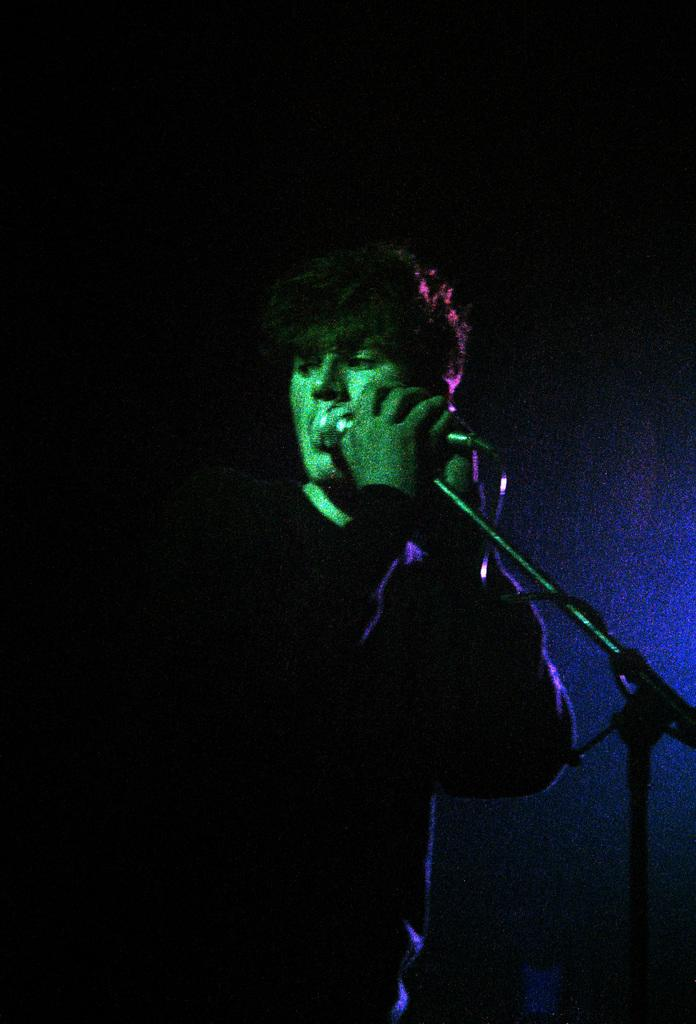What is the main subject of the image? There is a person standing in the image. What is the person holding in the image? The person is holding a mike stand. What color is the background of the image? The background of the image is black. Is the person sinking in quicksand in the image? There is no quicksand present in the image, so the person is not sinking in it. 